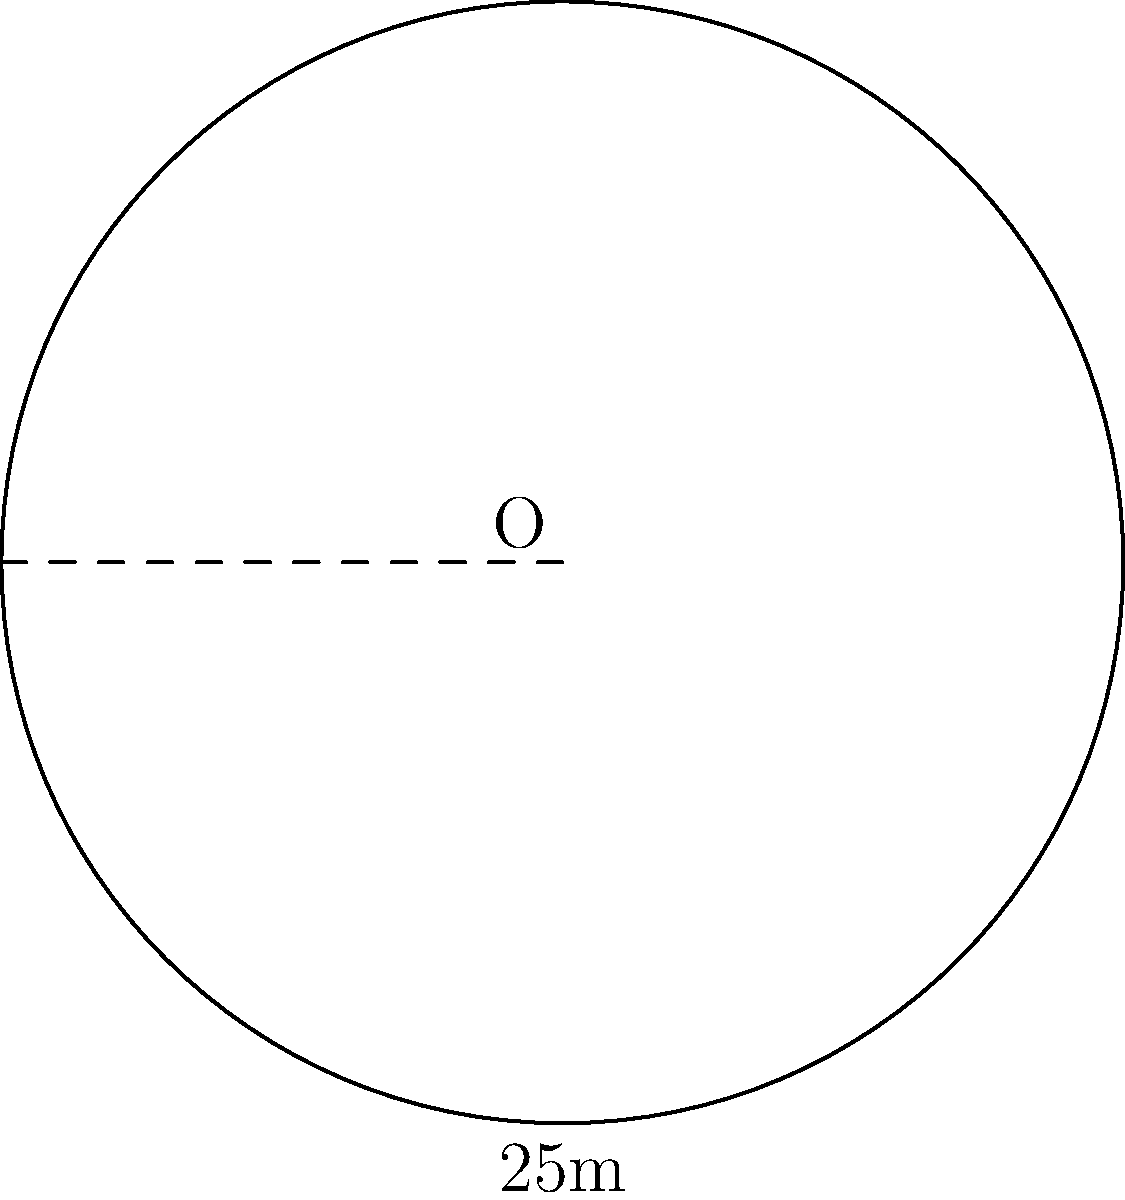You're designing a circular swimming pool for a new sports complex in Nairobi. The radius of the pool is 25 meters. Calculate the circumference of the pool to determine the length of safety railing needed around its perimeter. To solve this problem, we'll use the formula for the circumference of a circle:

$$C = 2\pi r$$

Where:
$C$ = circumference
$\pi$ = pi (approximately 3.14159)
$r$ = radius

Given:
$r = 25$ meters

Step 1: Substitute the given radius into the formula:
$$C = 2\pi(25)$$

Step 2: Multiply:
$$C = 50\pi$$

Step 3: Calculate the final value (using 3.14159 for $\pi$):
$$C = 50 * 3.14159 = 157.0795$$

Therefore, the circumference of the swimming pool is approximately 157.08 meters.
Answer: 157.08 meters 